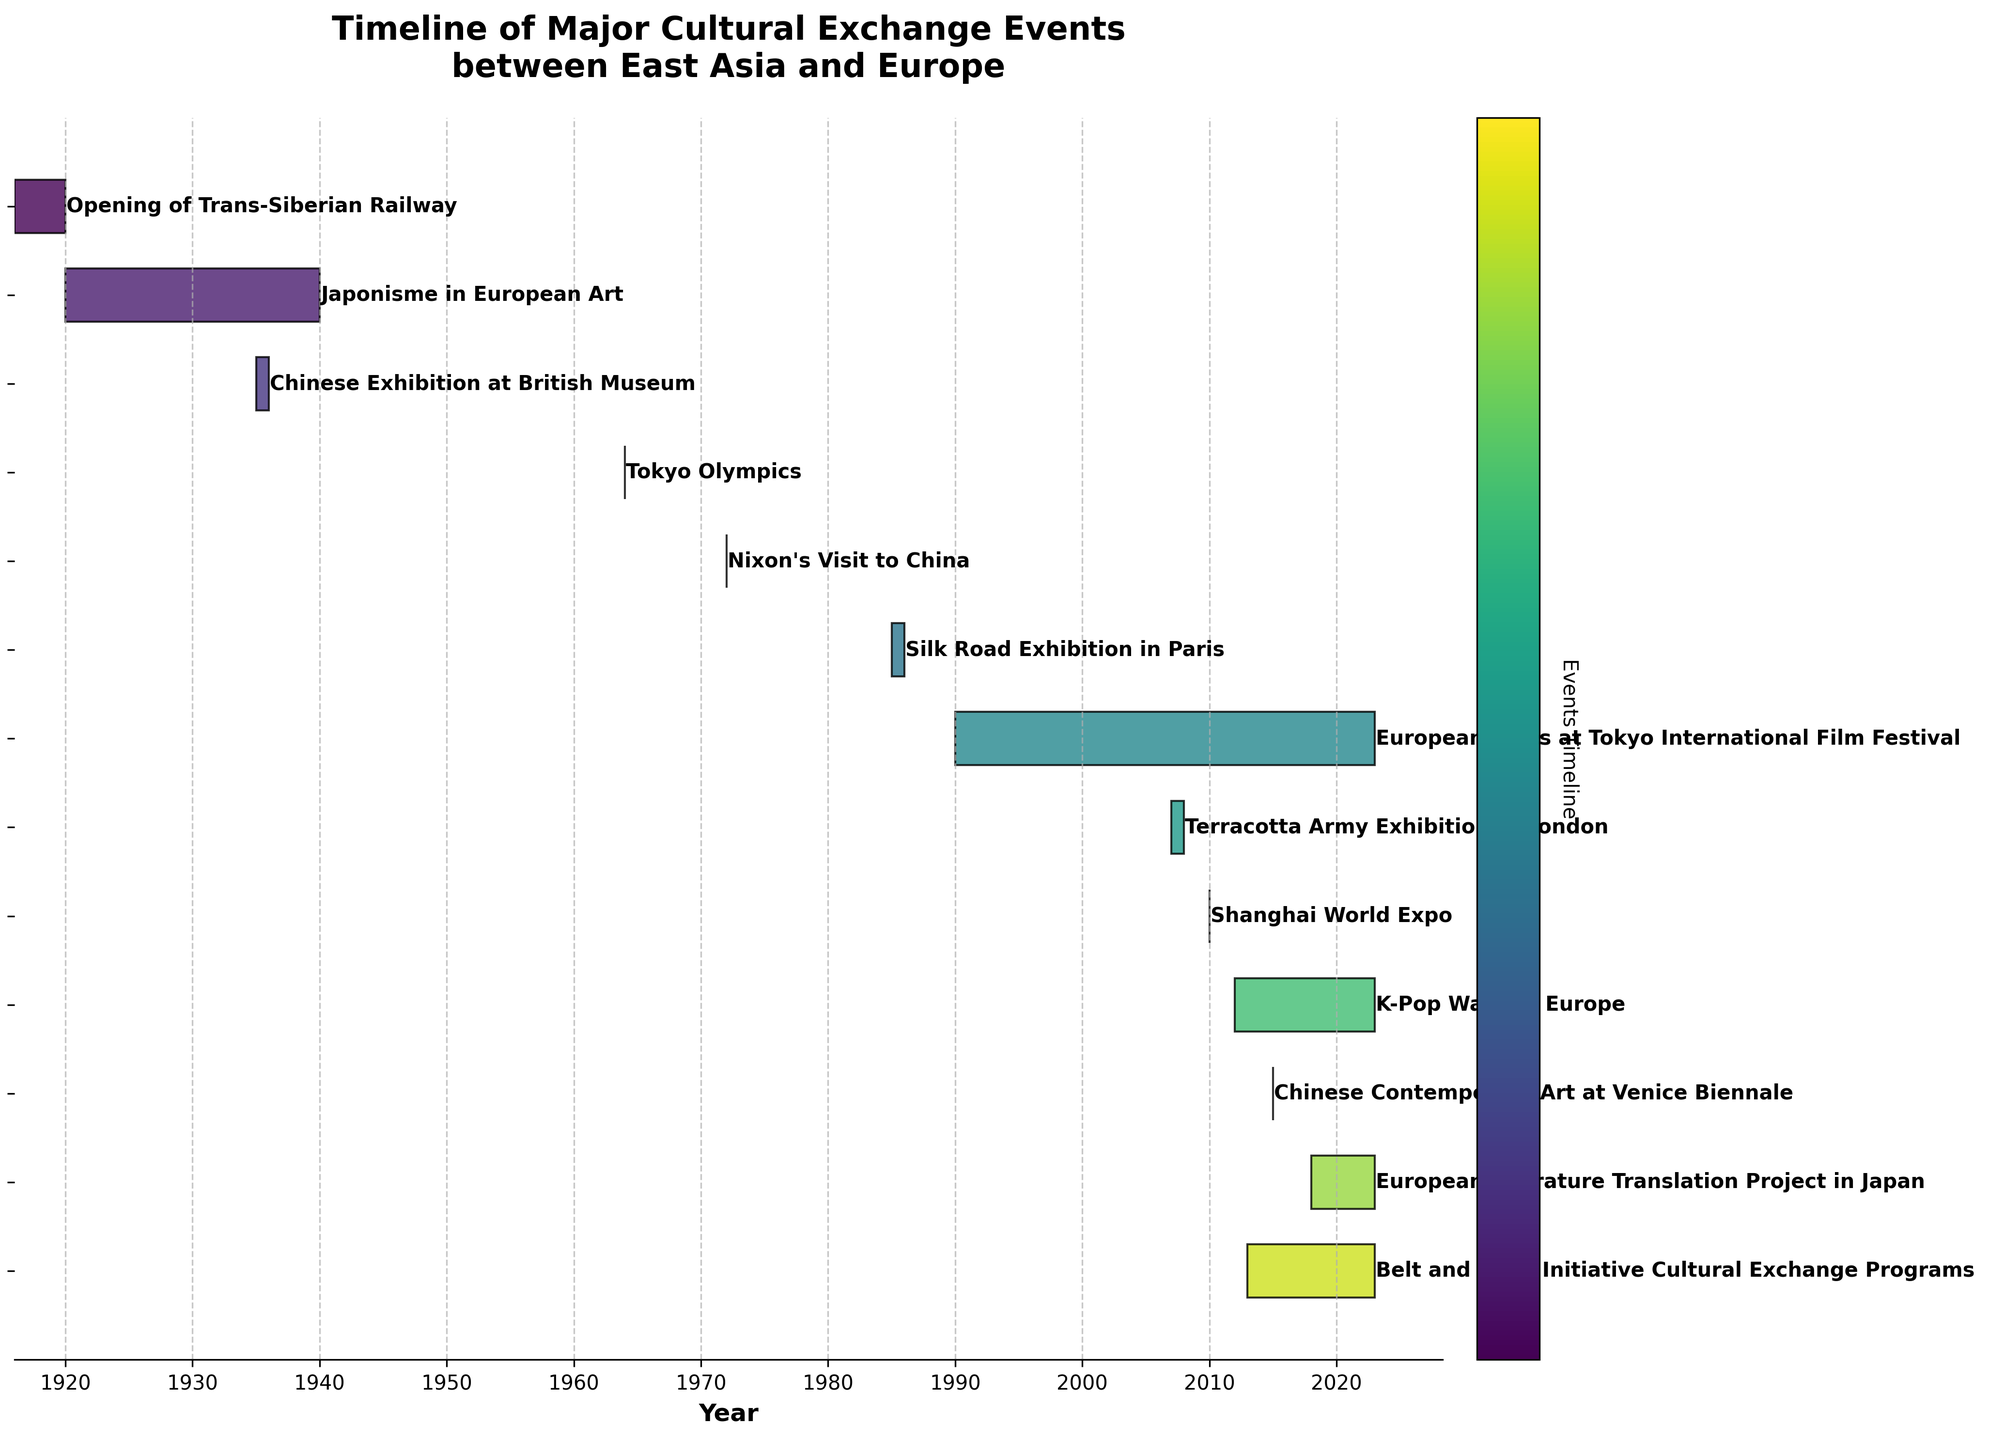What's the title of the chart? The title is located at the top of the chart and provides a brief description of the chart's subject. In this case, the title is "Timeline of Major Cultural Exchange Events between East Asia and Europe".
Answer: Timeline of Major Cultural Exchange Events between East Asia and Europe How many events are depicted in the chart? To determine this, count the number of horizontal bars on the Gantt chart, each of which represents an event. There are 13 such bars.
Answer: 13 Which event has the longest duration? Identify the bar that stretches across the most extended range on the horizontal axis. "European Films at Tokyo International Film Festival" spans from 1990 to 2023, the longest duration.
Answer: European Films at Tokyo International Film Festival What is the period of the "K-Pop Wave in Europe"? Look for the bar labeled "K-Pop Wave in Europe" and note its starting and ending points. It spans from 2012 to 2023.
Answer: 2012 to 2023 How many events lasted less than a year? Examine each bar and check their start and end dates. "Tokyo Olympics", "Nixon’s Visit to China", "Chinese Contemporary Art at Venice Biennale", "Chinese Exhibition at British Museum", and "Shanghai World Expo" lasted less than a year. There are 5 such events.
Answer: 5 Which event occurred first chronologically? Look for the bar that starts at the earliest point on the horizontal axis. The "Opening of Trans-Siberian Railway" starts in 1916, the earliest event.
Answer: Opening of Trans-Siberian Railway What is the time gap between the "Japonisme in European Art" event and "Chinese Exhibition at the British Museum"? Note the end date of "Japonisme in European Art" (1940) and the start date of the "Chinese Exhibition at British Museum" (1935). Subtract 1935 from 1940 to get the gap.
Answer: -5 years Which events were ongoing when the "Nixon’s Visit to China" took place in 1972? Identify ongoing events that overlap with 1972. "Japonisme in European Art" (1920-1940) and "European Films at Tokyo International Film Festival" (1990-2023) do not overlap with 1972, but the "Nixon’s Visit to China" itself does. There are no overlapping events.
Answer: None For how many years have there been cultural exchange programs under the "Belt and Road Initiative Cultural Exchange Programs"? Calculate the duration from the start in 2013 to 2023. Subtract 2013 from 2023.
Answer: 10 years Which events took place in exactly one calendar year? Find the bars that do not stretch beyond a single year. These events are "Tokyo Olympics" (1964), "Nixon’s Visit to China" (1972), "Chinese Contemporary Art at Venice Biennale" (2015), and "Shanghai World Expo" (2010). There are 4 such events.
Answer: 4 